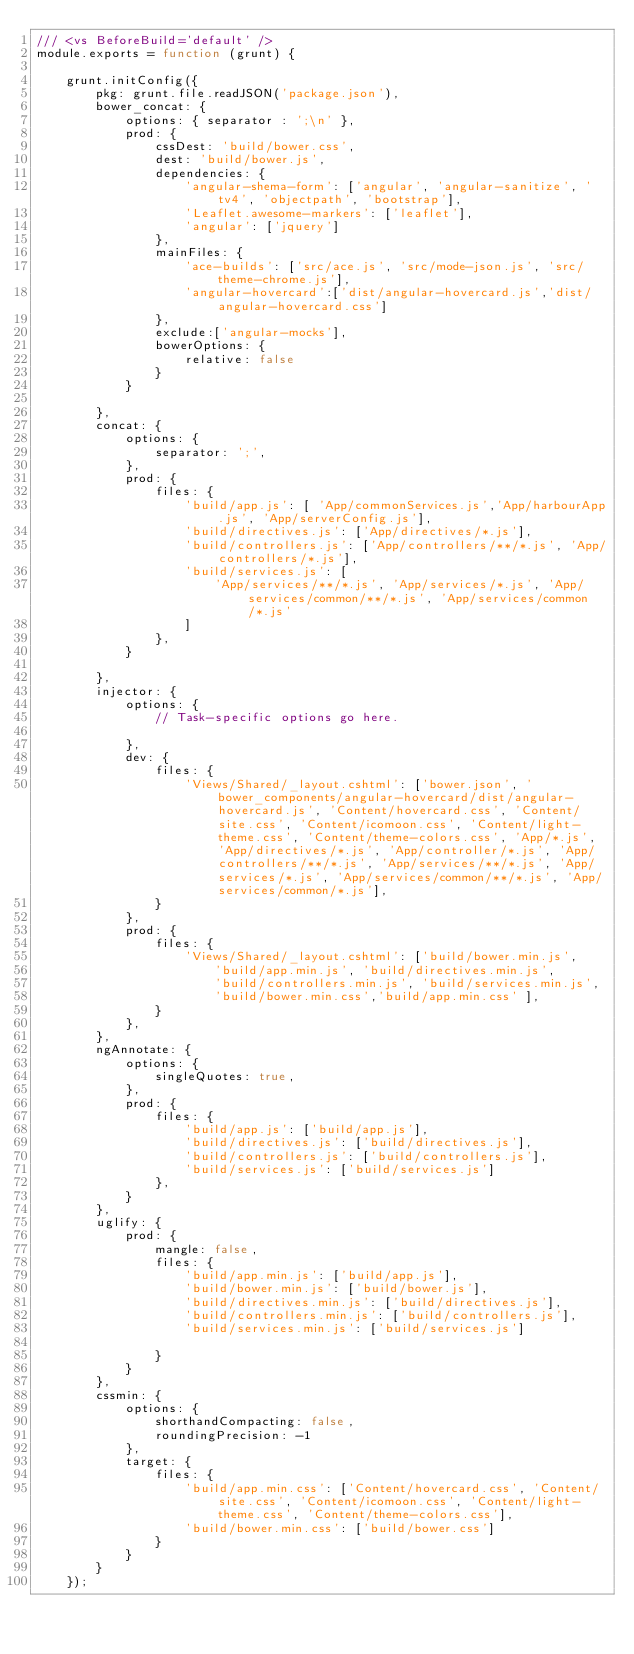<code> <loc_0><loc_0><loc_500><loc_500><_JavaScript_>/// <vs BeforeBuild='default' />
module.exports = function (grunt) {

    grunt.initConfig({
        pkg: grunt.file.readJSON('package.json'),
        bower_concat: {
            options: { separator : ';\n' },
            prod: {
                cssDest: 'build/bower.css',
                dest: 'build/bower.js',
                dependencies: {
                    'angular-shema-form': ['angular', 'angular-sanitize', 'tv4', 'objectpath', 'bootstrap'],
                    'Leaflet.awesome-markers': ['leaflet'],
                    'angular': ['jquery']
                },
                mainFiles: {
                    'ace-builds': ['src/ace.js', 'src/mode-json.js', 'src/theme-chrome.js'],
                    'angular-hovercard':['dist/angular-hovercard.js','dist/angular-hovercard.css']
                },
                exclude:['angular-mocks'],
                bowerOptions: {
                    relative: false
                }
            }

        },
        concat: {
            options: {
                separator: ';',
            },
            prod: {
                files: {
                    'build/app.js': [ 'App/commonServices.js','App/harbourApp.js', 'App/serverConfig.js'],
                    'build/directives.js': ['App/directives/*.js'],
                    'build/controllers.js': ['App/controllers/**/*.js', 'App/controllers/*.js'],
                    'build/services.js': [
                        'App/services/**/*.js', 'App/services/*.js', 'App/services/common/**/*.js', 'App/services/common/*.js'
                    ]
                },
            }

        },
        injector: {
            options: {
                // Task-specific options go here.

            },
            dev: {
                files: {
                    'Views/Shared/_layout.cshtml': ['bower.json', 'bower_components/angular-hovercard/dist/angular-hovercard.js', 'Content/hovercard.css', 'Content/site.css', 'Content/icomoon.css', 'Content/light-theme.css', 'Content/theme-colors.css', 'App/*.js', 'App/directives/*.js', 'App/controller/*.js', 'App/controllers/**/*.js', 'App/services/**/*.js', 'App/services/*.js', 'App/services/common/**/*.js', 'App/services/common/*.js'],
                }
            },
            prod: {
                files: {
                    'Views/Shared/_layout.cshtml': ['build/bower.min.js',
                        'build/app.min.js', 'build/directives.min.js',
                        'build/controllers.min.js', 'build/services.min.js',
                        'build/bower.min.css','build/app.min.css' ],
                }
            },
        },
        ngAnnotate: {
            options: {
                singleQuotes: true,
            },
            prod: {
                files: {
                    'build/app.js': ['build/app.js'],
                    'build/directives.js': ['build/directives.js'],
                    'build/controllers.js': ['build/controllers.js'],
                    'build/services.js': ['build/services.js']
                },
            }
        },
        uglify: {
            prod: {
                mangle: false,
                files: {
                    'build/app.min.js': ['build/app.js'],
                    'build/bower.min.js': ['build/bower.js'],
                    'build/directives.min.js': ['build/directives.js'],
                    'build/controllers.min.js': ['build/controllers.js'],
                    'build/services.min.js': ['build/services.js']

                }
            }
        },
        cssmin: {
            options: {
                shorthandCompacting: false,
                roundingPrecision: -1
            },
            target: {
                files: {
                    'build/app.min.css': ['Content/hovercard.css', 'Content/site.css', 'Content/icomoon.css', 'Content/light-theme.css', 'Content/theme-colors.css'],
                    'build/bower.min.css': ['build/bower.css']
                }
            }
        }
    });
</code> 